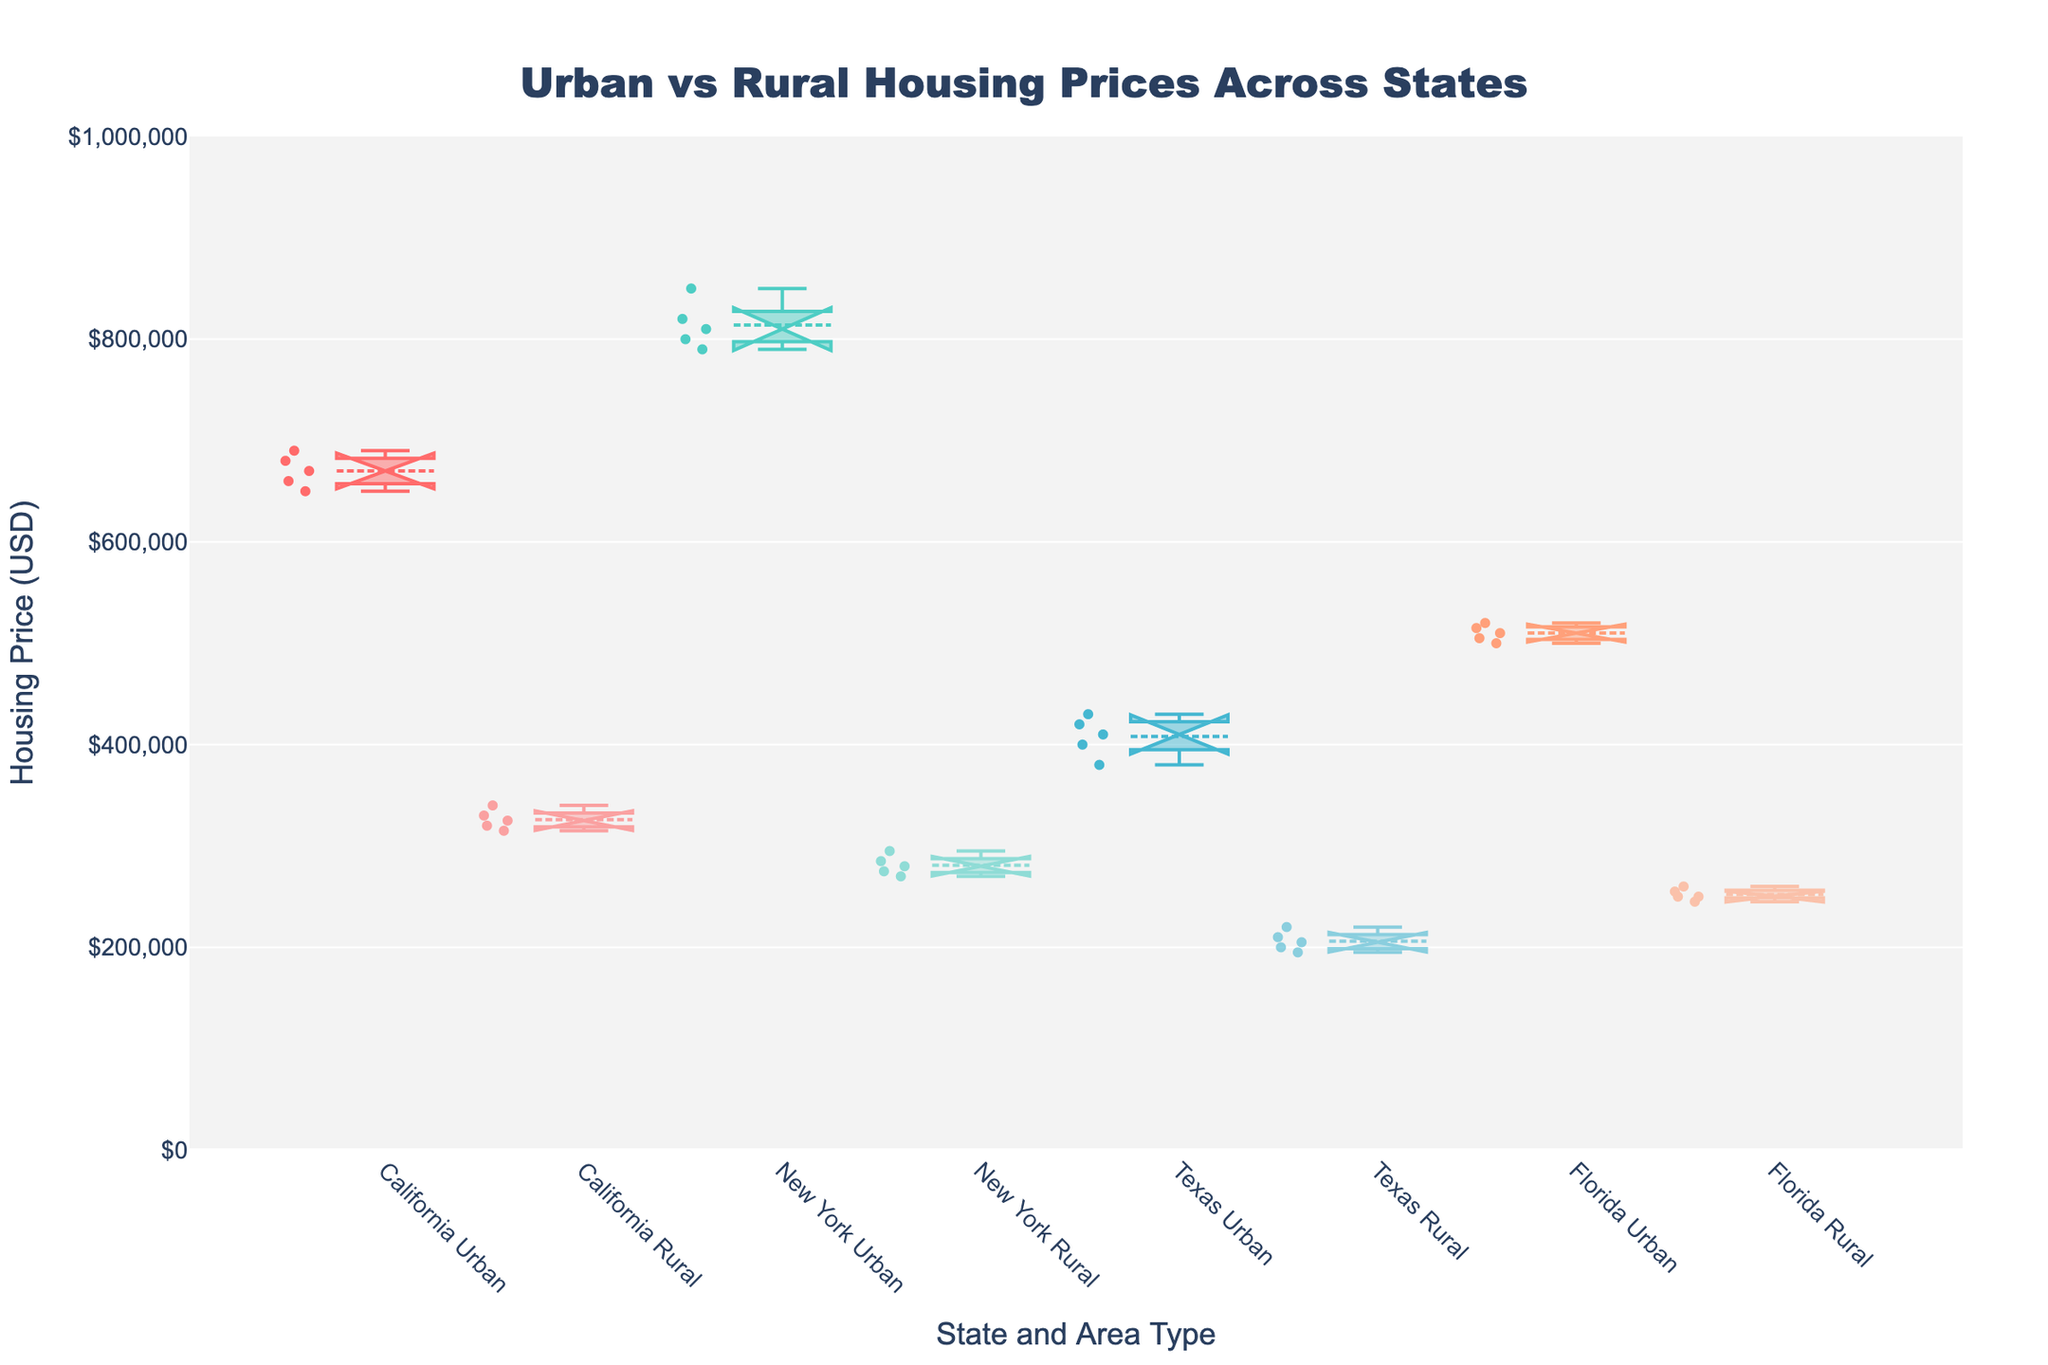What is the title of the plot? The title of the plot is typically displayed at the top of the figure. It helps to understand what the figure represents. The title here is "Urban vs Rural Housing Prices Across States."
Answer: Urban vs Rural Housing Prices Across States How are urban and rural areas differentiated in the plot? Urban and rural areas in the plot are differentiated by their specific colors and titles on the x-axis. Each state has two boxes: one for Urban and one for Rural.
Answer: Colors and Titles on the x-axis Which state has the highest median housing price in urban areas? To determine the highest median price, look at the middle line in the respective urban box plots across states. The highest median line is in the New York Urban box.
Answer: New York What is the range of housing prices in Florida's rural areas? The range is determined by the bottom and top edges of the box (lower and upper quartile) and the whiskers in Florida Rural box. The whiskers typically represent the minimum and maximum values. In the Florida Rural box, the range is roughly from $245,000 to $260,000.
Answer: $245,000 to $260,000 Which area, urban or rural, has the highest variability in housing prices within Texas? Variability can be assessed by looking at the height of the boxes and the length of the whiskers. The Texas Urban box has a wider spread with longer whiskers compared to Texas Rural, indicating higher variability.
Answer: Urban Do any states show an overlap in housing prices between urban and rural areas based on the notches? Overlaps can be identified by seeing if the notches on two boxes intersect. In this plot, California's notches intersect, indicating an overlap in housing prices between urban and rural areas.
Answer: California Which state has the lowest median housing price in rural areas? Look for the box with the lowest median line in the rural areas. The lowest median line among rural areas appears in New York.
Answer: New York Is the mean housing price higher in urban or rural areas for Florida? Mean values are marked by the dashed lines or different markers in the boxes. For Florida, the mean in urban areas is higher compared to rural areas.
Answer: Urban Are there any outliers in California's urban housing prices? Outliers are typically represented by individual points outside the whiskers of a box plot. In California's urban box, there are no visible outlier points beyond the whiskers, suggesting no outliers.
Answer: No 